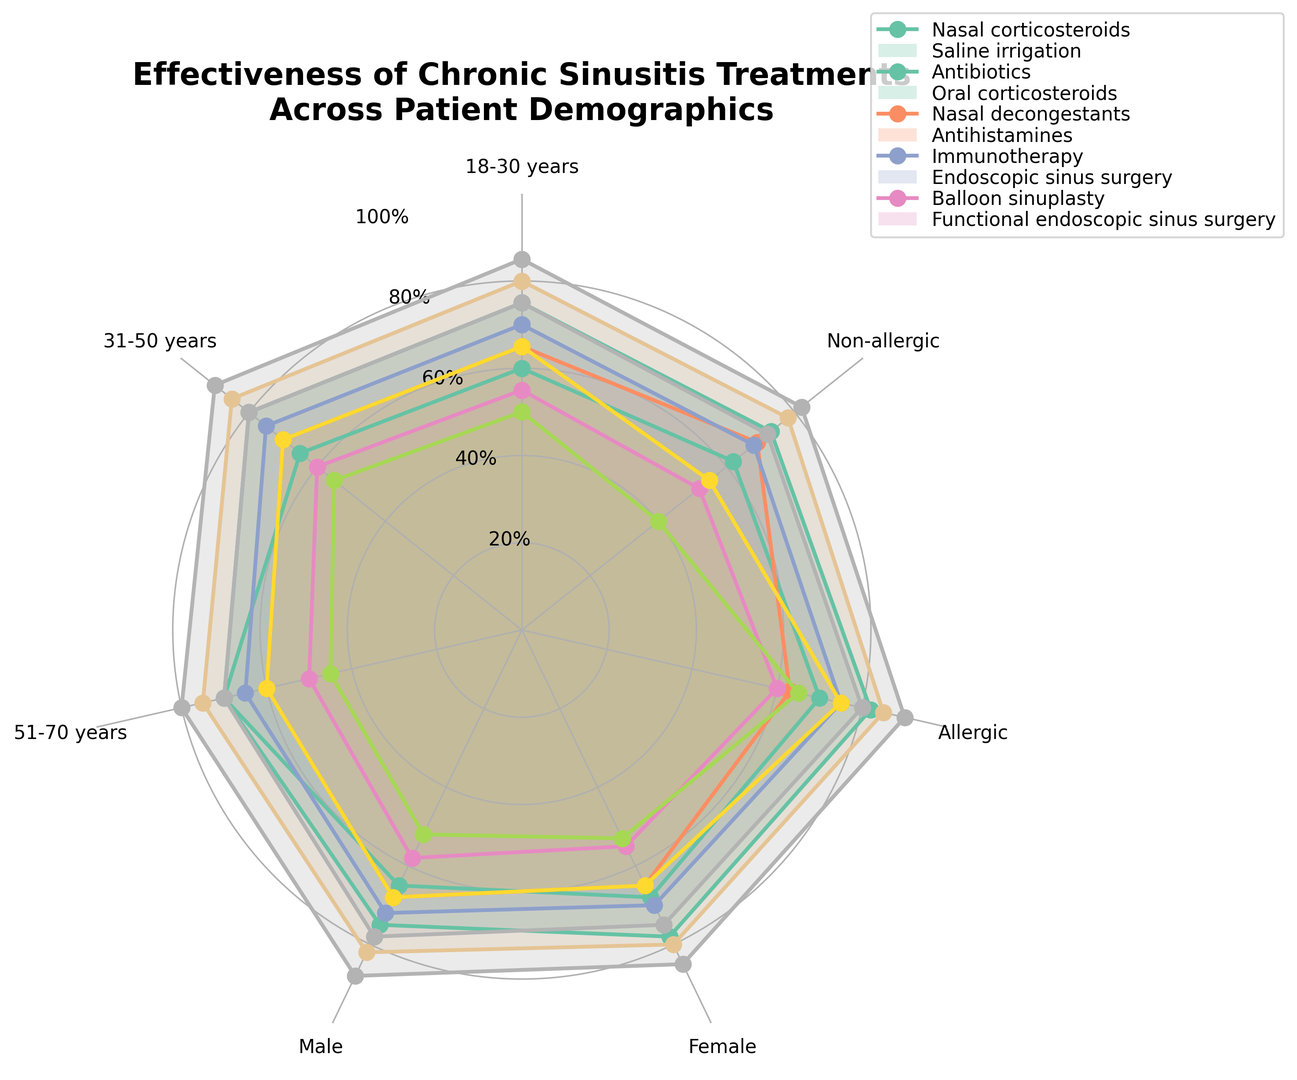What's the most effective treatment for patients aged 31-50 years? By observing the radar chart, you can see that 'Functional endoscopic sinus surgery' has the highest point (90) among all treatments for the 31-50 years age group.
Answer: Functional endoscopic sinus surgery Which treatment shows the largest difference in effectiveness between allergic and non-allergic patients? By looking at the distances between the points of each treatment for allergic and non-allergic patients, 'Antihistamines' exhibits the largest difference: 65 (allergic) and 40 (non-allergic), resulting in a difference of 25.
Answer: Antihistamines What is the average effectiveness of Nasal corticosteroids across all patient demographics? The values for Nasal corticosteroids are [75, 80, 70, 75, 78, 82, 73]. Adding these values and dividing by the number of demographics (7) gives (75+80+70+75+78+82+73)/7 = 533/7 ≈ 76.14.
Answer: ~76.14 Between Male and Female patients, which group shows higher effectiveness for Balloon sinuplasty? Balloon sinuplasty effectiveness is 78 for Male patients and 75 for Female patients. Therefore, it shows higher effectiveness in Male patients.
Answer: Male For patients aged 51-70, which treatment is the least effective? Looking at the points for the 51-70 years age group, 'Antihistamines' has the lowest value (45), making it the least effective treatment for this group.
Answer: Antihistamines Compare the effectiveness of Endoscopic sinus surgery and Balloon sinuplasty for allergic patients. Which treatment is more effective? Observing the radar chart, Endoscopic sinus surgery has a value of 85 for allergic patients, whereas Balloon sinuplasty has a value of 80. Therefore, Endoscopic sinus surgery is more effective.
Answer: Endoscopic sinus surgery How does the effectiveness of Oral corticosteroids in Female patients compare to its effectiveness in Male patients? The effectiveness of Oral corticosteroids in Female patients is 70, and in Male patients, it is 72. Therefore, it is slightly more effective in Male patients.
Answer: Slightly more effective in Male patients 